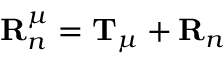<formula> <loc_0><loc_0><loc_500><loc_500>R _ { n } ^ { \mu } = T _ { \mu } + R _ { n }</formula> 